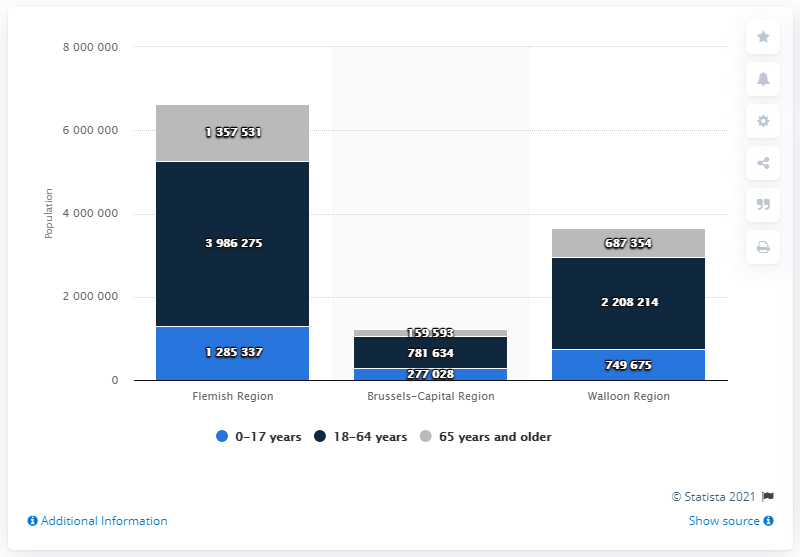Specify some key components in this picture. In 2020, there were approximately 159,593 people aged 65 or older in the Brussels-Capital Region. In 2020, the Brussels-Capital Region was home to approximately 277,028 people. 